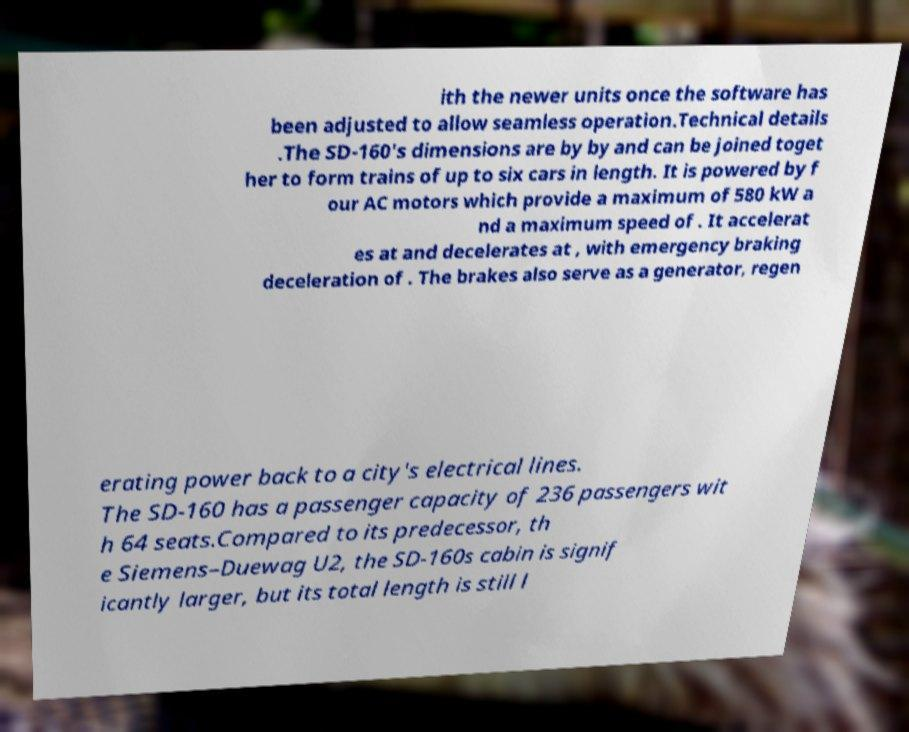For documentation purposes, I need the text within this image transcribed. Could you provide that? ith the newer units once the software has been adjusted to allow seamless operation.Technical details .The SD-160's dimensions are by by and can be joined toget her to form trains of up to six cars in length. It is powered by f our AC motors which provide a maximum of 580 kW a nd a maximum speed of . It accelerat es at and decelerates at , with emergency braking deceleration of . The brakes also serve as a generator, regen erating power back to a city's electrical lines. The SD-160 has a passenger capacity of 236 passengers wit h 64 seats.Compared to its predecessor, th e Siemens–Duewag U2, the SD-160s cabin is signif icantly larger, but its total length is still l 